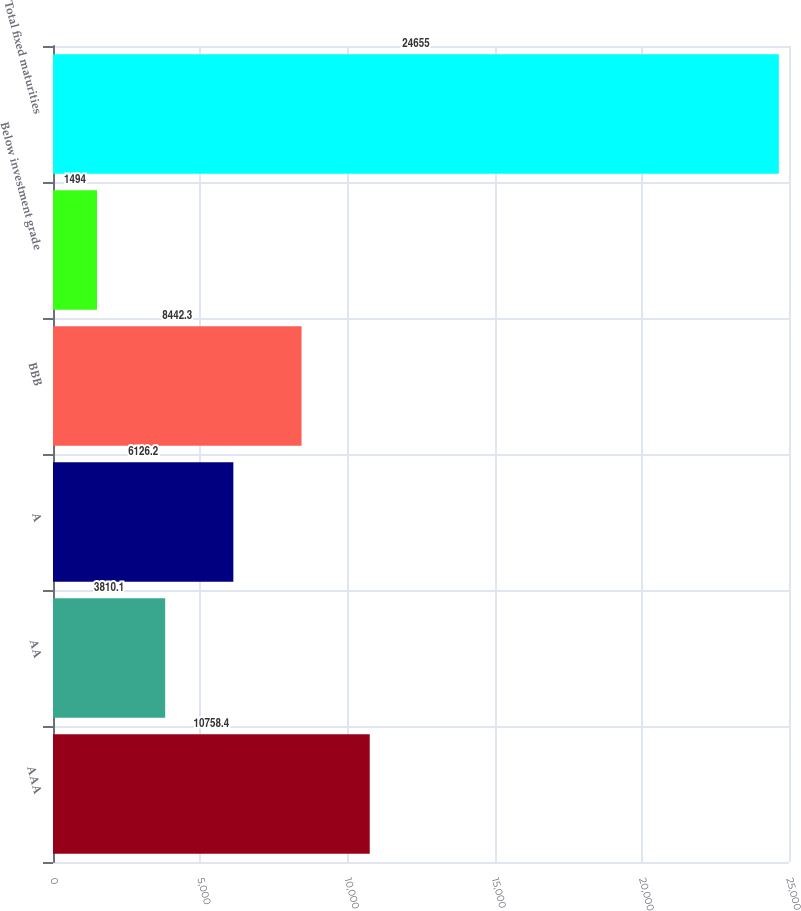Convert chart to OTSL. <chart><loc_0><loc_0><loc_500><loc_500><bar_chart><fcel>AAA<fcel>AA<fcel>A<fcel>BBB<fcel>Below investment grade<fcel>Total fixed maturities<nl><fcel>10758.4<fcel>3810.1<fcel>6126.2<fcel>8442.3<fcel>1494<fcel>24655<nl></chart> 